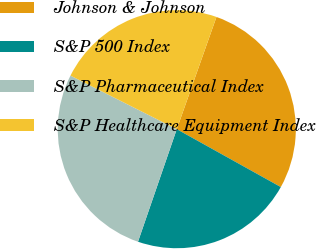Convert chart to OTSL. <chart><loc_0><loc_0><loc_500><loc_500><pie_chart><fcel>Johnson & Johnson<fcel>S&P 500 Index<fcel>S&P Pharmaceutical Index<fcel>S&P Healthcare Equipment Index<nl><fcel>27.67%<fcel>22.2%<fcel>27.15%<fcel>22.98%<nl></chart> 